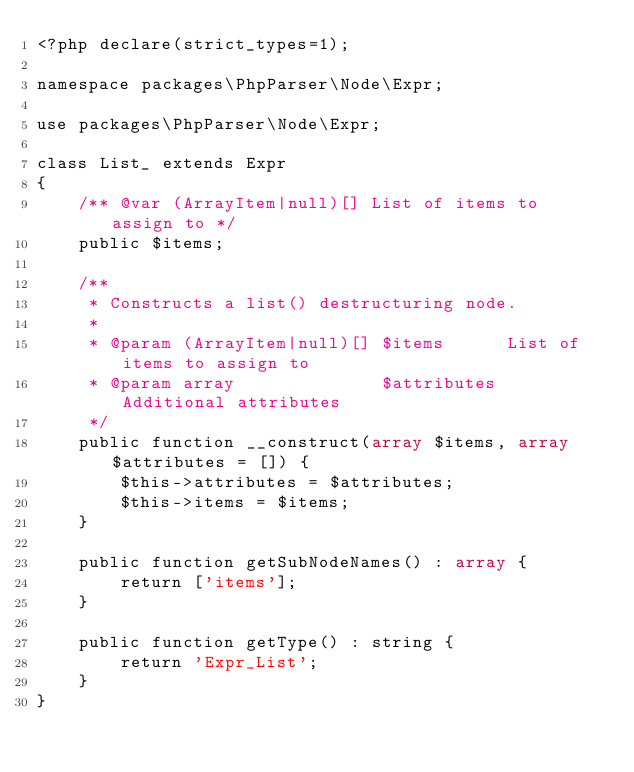<code> <loc_0><loc_0><loc_500><loc_500><_PHP_><?php declare(strict_types=1);

namespace packages\PhpParser\Node\Expr;

use packages\PhpParser\Node\Expr;

class List_ extends Expr
{
    /** @var (ArrayItem|null)[] List of items to assign to */
    public $items;

    /**
     * Constructs a list() destructuring node.
     *
     * @param (ArrayItem|null)[] $items      List of items to assign to
     * @param array              $attributes Additional attributes
     */
    public function __construct(array $items, array $attributes = []) {
        $this->attributes = $attributes;
        $this->items = $items;
    }

    public function getSubNodeNames() : array {
        return ['items'];
    }
    
    public function getType() : string {
        return 'Expr_List';
    }
}
</code> 